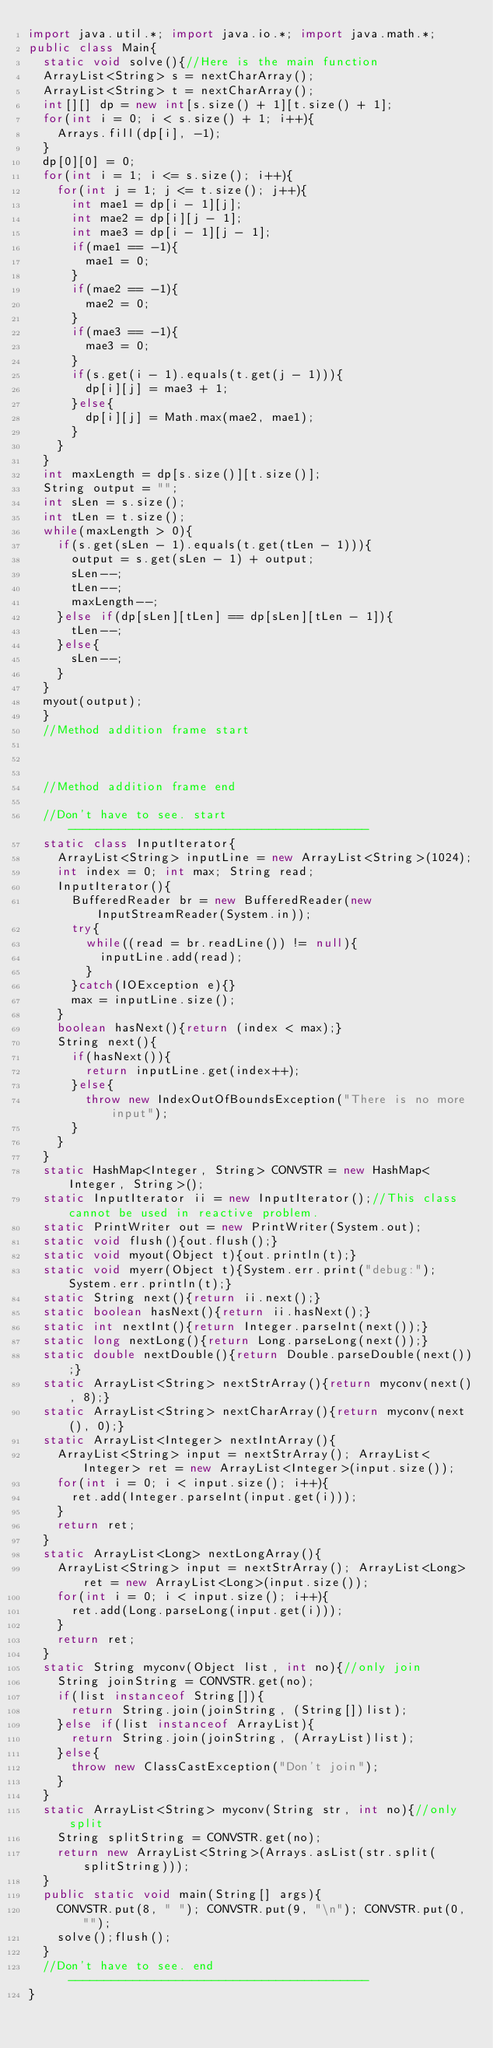Convert code to text. <code><loc_0><loc_0><loc_500><loc_500><_Java_>import java.util.*; import java.io.*; import java.math.*;
public class Main{
	static void solve(){//Here is the main function
	ArrayList<String> s = nextCharArray();
	ArrayList<String> t = nextCharArray();
	int[][] dp = new int[s.size() + 1][t.size() + 1];
	for(int i = 0; i < s.size() + 1; i++){
		Arrays.fill(dp[i], -1);
	}
	dp[0][0] = 0;
	for(int i = 1; i <= s.size(); i++){
		for(int j = 1; j <= t.size(); j++){
			int mae1 = dp[i - 1][j];
			int mae2 = dp[i][j - 1];
			int mae3 = dp[i - 1][j - 1];
			if(mae1 == -1){
				mae1 = 0;
			}
			if(mae2 == -1){
				mae2 = 0;
			}
			if(mae3 == -1){
				mae3 = 0;
			}
			if(s.get(i - 1).equals(t.get(j - 1))){
				dp[i][j] = mae3 + 1;
			}else{
				dp[i][j] = Math.max(mae2, mae1);
			}
		}
	}
	int maxLength = dp[s.size()][t.size()];
	String output = "";
	int sLen = s.size();
	int tLen = t.size();
	while(maxLength > 0){
		if(s.get(sLen - 1).equals(t.get(tLen - 1))){
			output = s.get(sLen - 1) + output;
			sLen--;
			tLen--;
			maxLength--;
		}else if(dp[sLen][tLen] == dp[sLen][tLen - 1]){
			tLen--;
		}else{
			sLen--;
		}
	}
	myout(output);
	}
	//Method addition frame start



	//Method addition frame end

	//Don't have to see. start------------------------------------------
	static class InputIterator{
		ArrayList<String> inputLine = new ArrayList<String>(1024);
		int index = 0; int max; String read;
		InputIterator(){
			BufferedReader br = new BufferedReader(new InputStreamReader(System.in));
			try{
				while((read = br.readLine()) != null){
					inputLine.add(read);
				}
			}catch(IOException e){}
			max = inputLine.size();
		}
		boolean hasNext(){return (index < max);}
		String next(){
			if(hasNext()){
				return inputLine.get(index++);
			}else{
				throw new IndexOutOfBoundsException("There is no more input");
			}
		}
	}
	static HashMap<Integer, String> CONVSTR = new HashMap<Integer, String>();
	static InputIterator ii = new InputIterator();//This class cannot be used in reactive problem.
	static PrintWriter out = new PrintWriter(System.out);
	static void flush(){out.flush();}
	static void myout(Object t){out.println(t);}
	static void myerr(Object t){System.err.print("debug:");System.err.println(t);}
	static String next(){return ii.next();}
	static boolean hasNext(){return ii.hasNext();}
	static int nextInt(){return Integer.parseInt(next());}
	static long nextLong(){return Long.parseLong(next());}
	static double nextDouble(){return Double.parseDouble(next());}
	static ArrayList<String> nextStrArray(){return myconv(next(), 8);}
	static ArrayList<String> nextCharArray(){return myconv(next(), 0);}
	static ArrayList<Integer> nextIntArray(){
		ArrayList<String> input = nextStrArray(); ArrayList<Integer> ret = new ArrayList<Integer>(input.size());
		for(int i = 0; i < input.size(); i++){
			ret.add(Integer.parseInt(input.get(i)));
		}
		return ret;
	}
	static ArrayList<Long> nextLongArray(){
		ArrayList<String> input = nextStrArray(); ArrayList<Long> ret = new ArrayList<Long>(input.size());
		for(int i = 0; i < input.size(); i++){
			ret.add(Long.parseLong(input.get(i)));
		}
		return ret;
	}
	static String myconv(Object list, int no){//only join
		String joinString = CONVSTR.get(no);
		if(list instanceof String[]){
			return String.join(joinString, (String[])list);
		}else if(list instanceof ArrayList){
			return String.join(joinString, (ArrayList)list);
		}else{
			throw new ClassCastException("Don't join");
		}
	}
	static ArrayList<String> myconv(String str, int no){//only split
		String splitString = CONVSTR.get(no);
		return new ArrayList<String>(Arrays.asList(str.split(splitString)));
	}
	public static void main(String[] args){
		CONVSTR.put(8, " "); CONVSTR.put(9, "\n"); CONVSTR.put(0, "");
		solve();flush();
	}
	//Don't have to see. end------------------------------------------
}
</code> 